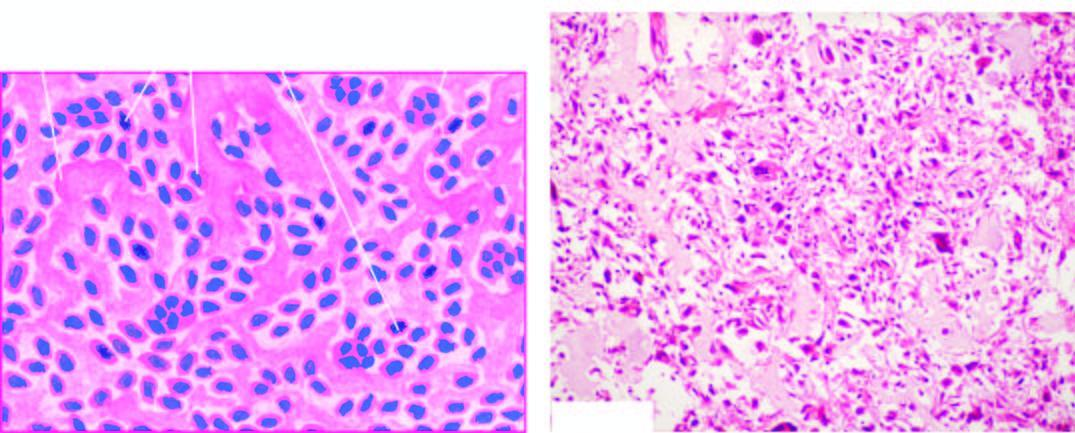re hallmarks of microscopic picture of the usual osteosarcoma the sarcoma cells characterised by variation in size and shape of tumour cells, bizarre mitosis and multinucleate tumour giant cells, and osteogenesis ie?
Answer the question using a single word or phrase. Yes 